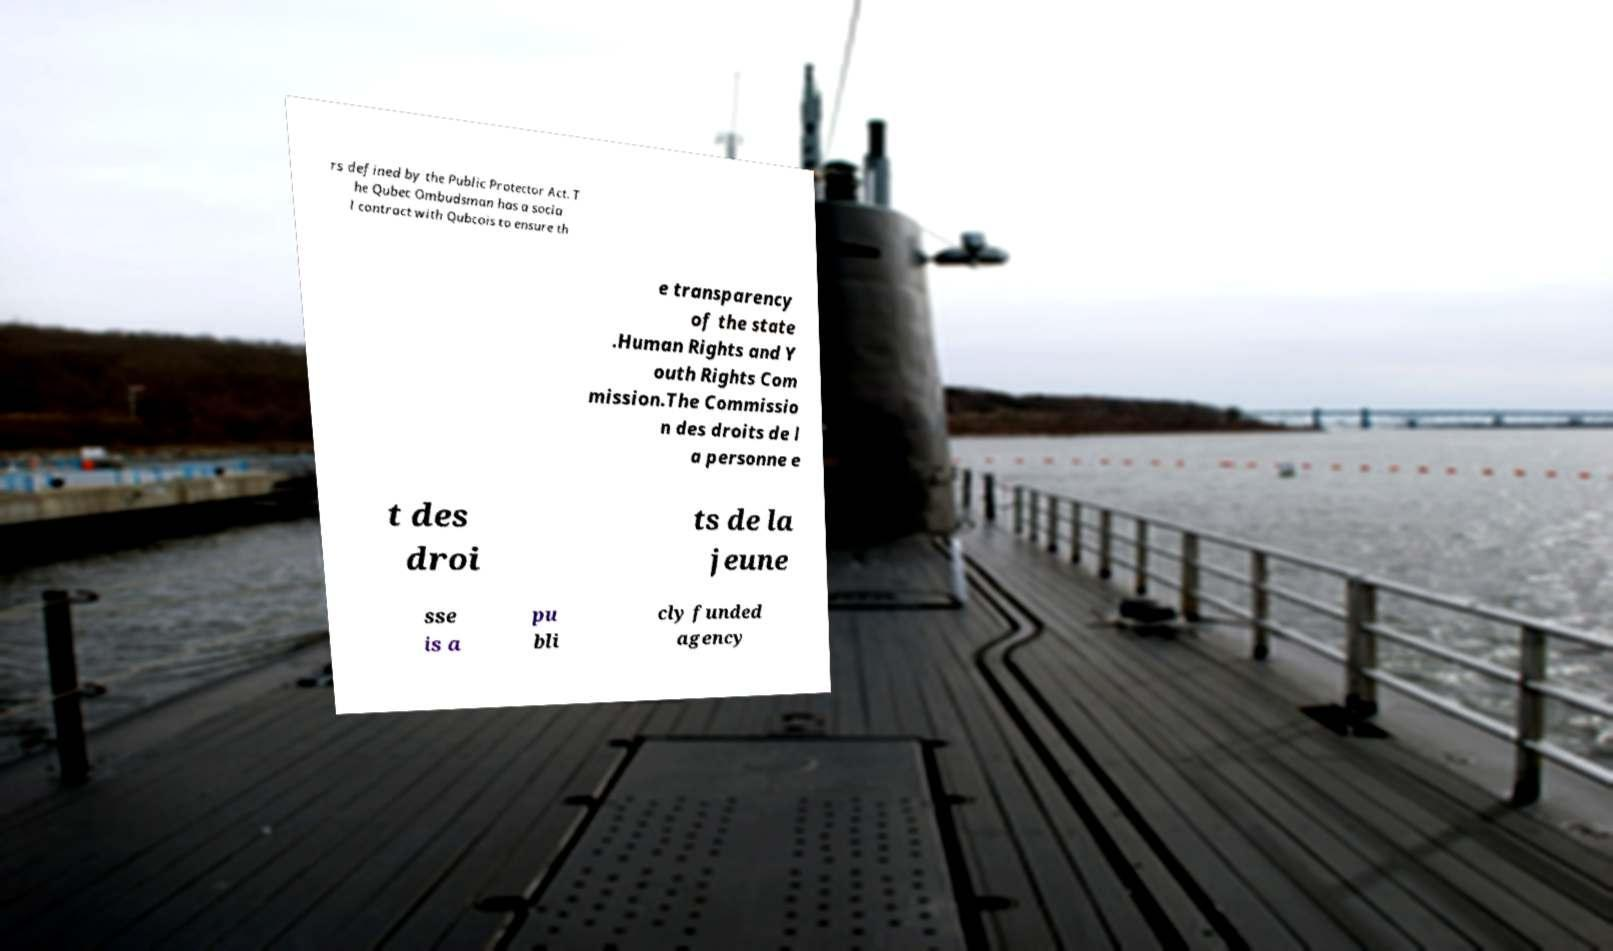Please identify and transcribe the text found in this image. rs defined by the Public Protector Act. T he Qubec Ombudsman has a socia l contract with Qubcois to ensure th e transparency of the state .Human Rights and Y outh Rights Com mission.The Commissio n des droits de l a personne e t des droi ts de la jeune sse is a pu bli cly funded agency 